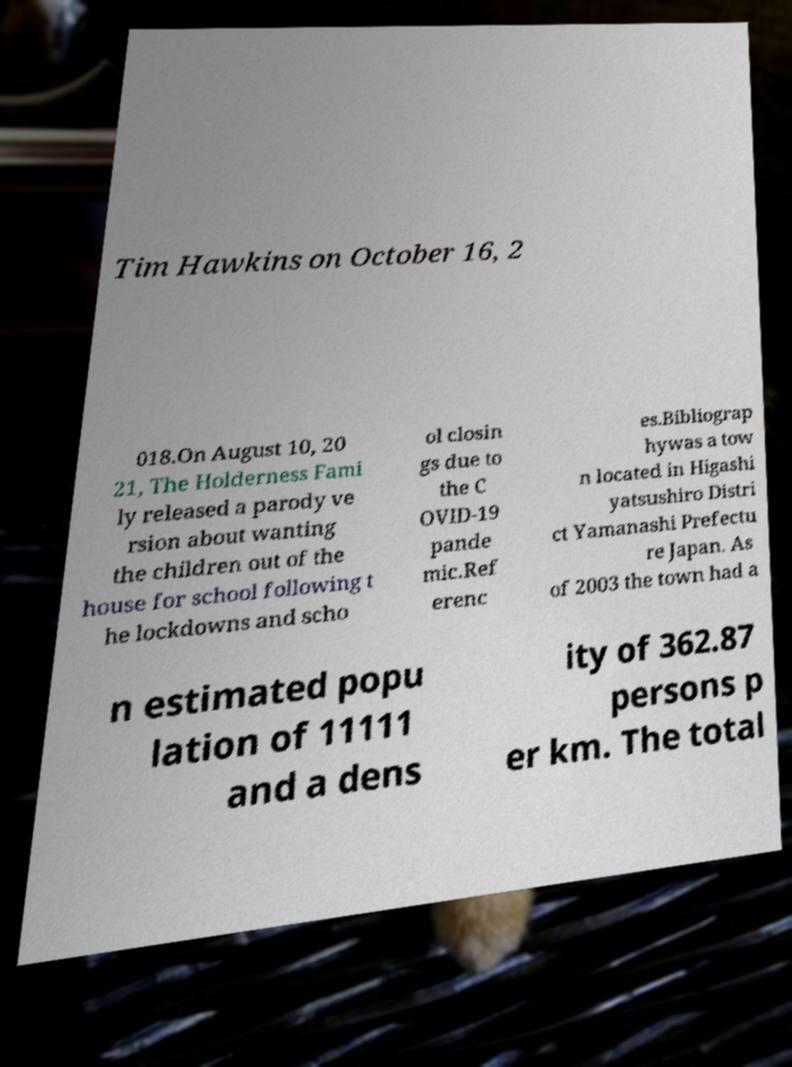Could you extract and type out the text from this image? Tim Hawkins on October 16, 2 018.On August 10, 20 21, The Holderness Fami ly released a parody ve rsion about wanting the children out of the house for school following t he lockdowns and scho ol closin gs due to the C OVID-19 pande mic.Ref erenc es.Bibliograp hywas a tow n located in Higashi yatsushiro Distri ct Yamanashi Prefectu re Japan. As of 2003 the town had a n estimated popu lation of 11111 and a dens ity of 362.87 persons p er km. The total 